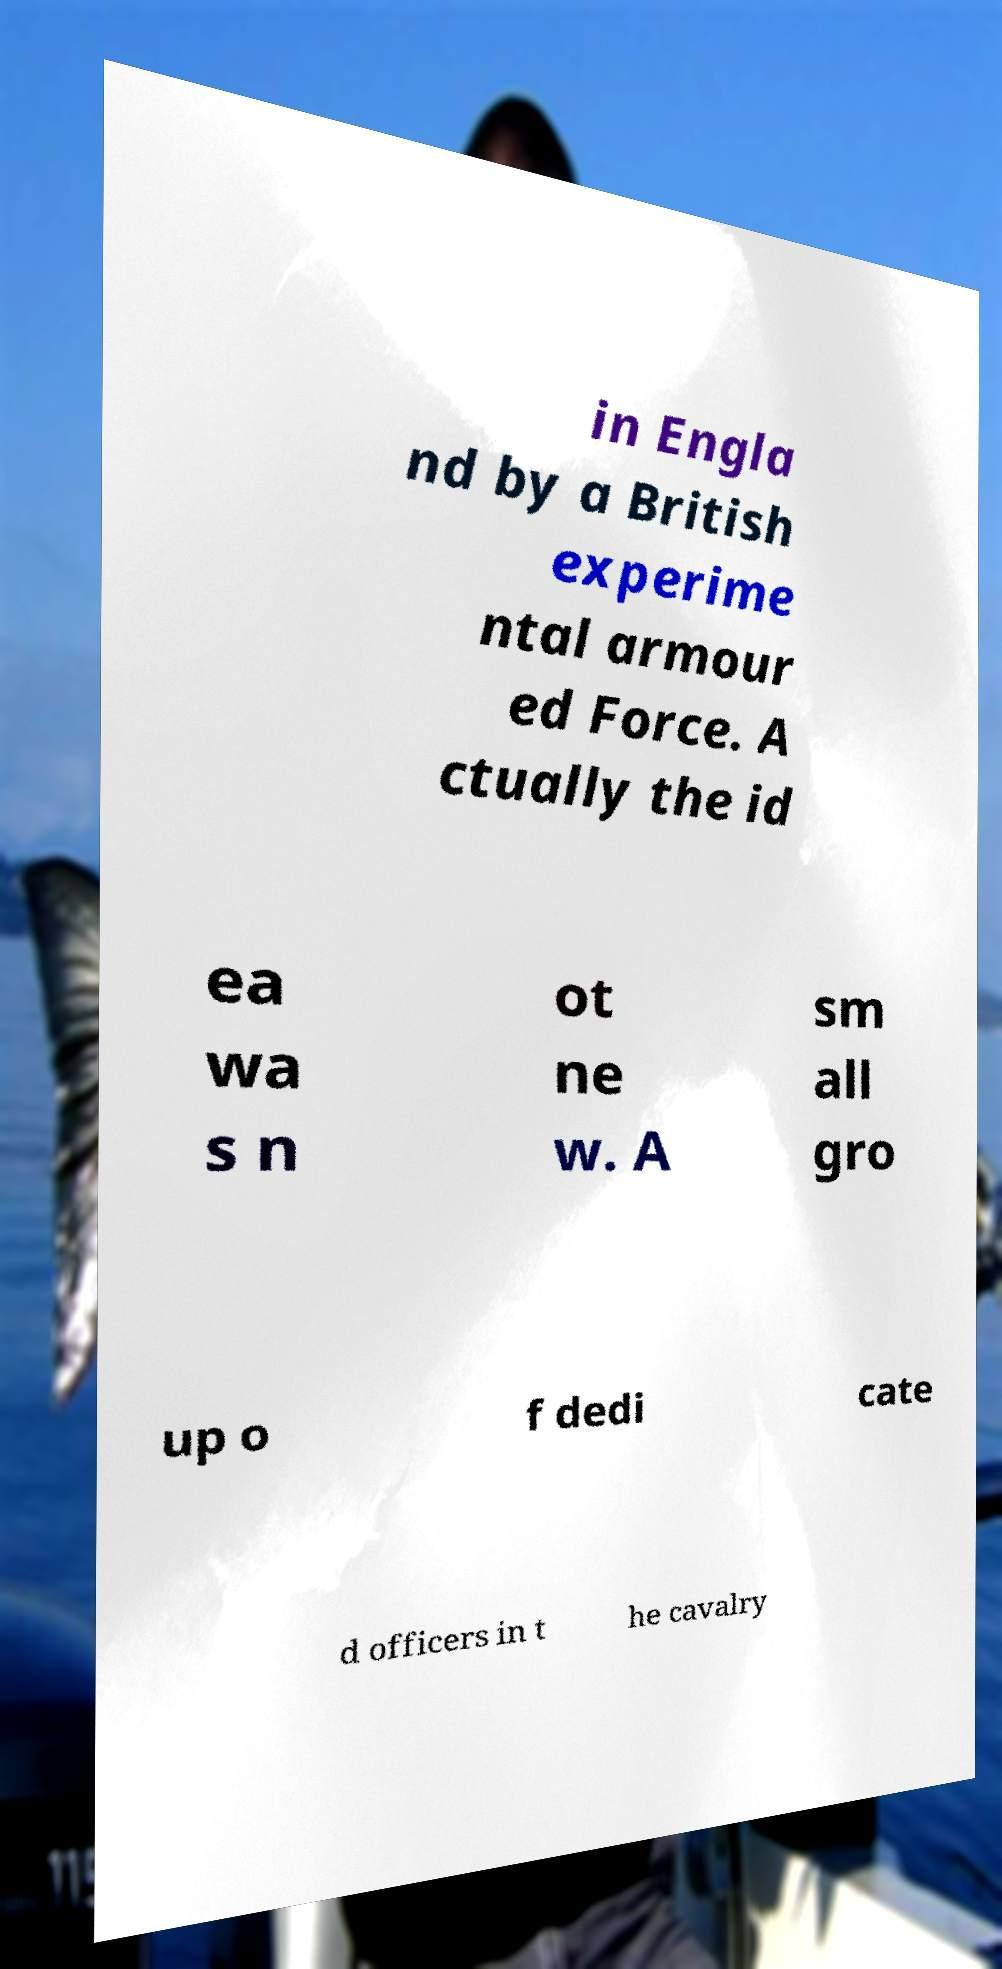There's text embedded in this image that I need extracted. Can you transcribe it verbatim? in Engla nd by a British experime ntal armour ed Force. A ctually the id ea wa s n ot ne w. A sm all gro up o f dedi cate d officers in t he cavalry 